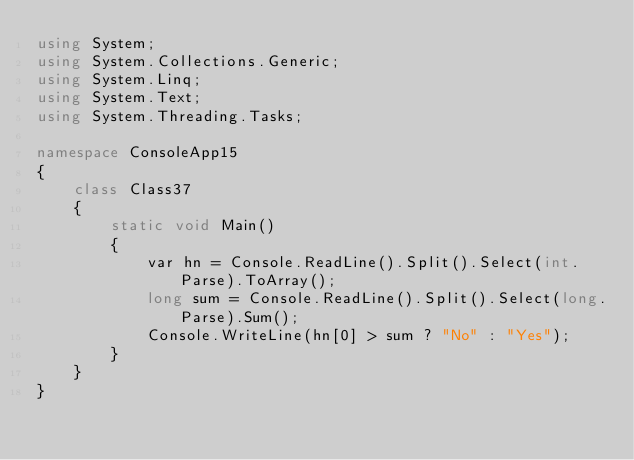Convert code to text. <code><loc_0><loc_0><loc_500><loc_500><_C#_>using System;
using System.Collections.Generic;
using System.Linq;
using System.Text;
using System.Threading.Tasks;

namespace ConsoleApp15
{
    class Class37
    {
        static void Main()
        {
            var hn = Console.ReadLine().Split().Select(int.Parse).ToArray();
            long sum = Console.ReadLine().Split().Select(long.Parse).Sum();
            Console.WriteLine(hn[0] > sum ? "No" : "Yes");
        }
    }
}
</code> 